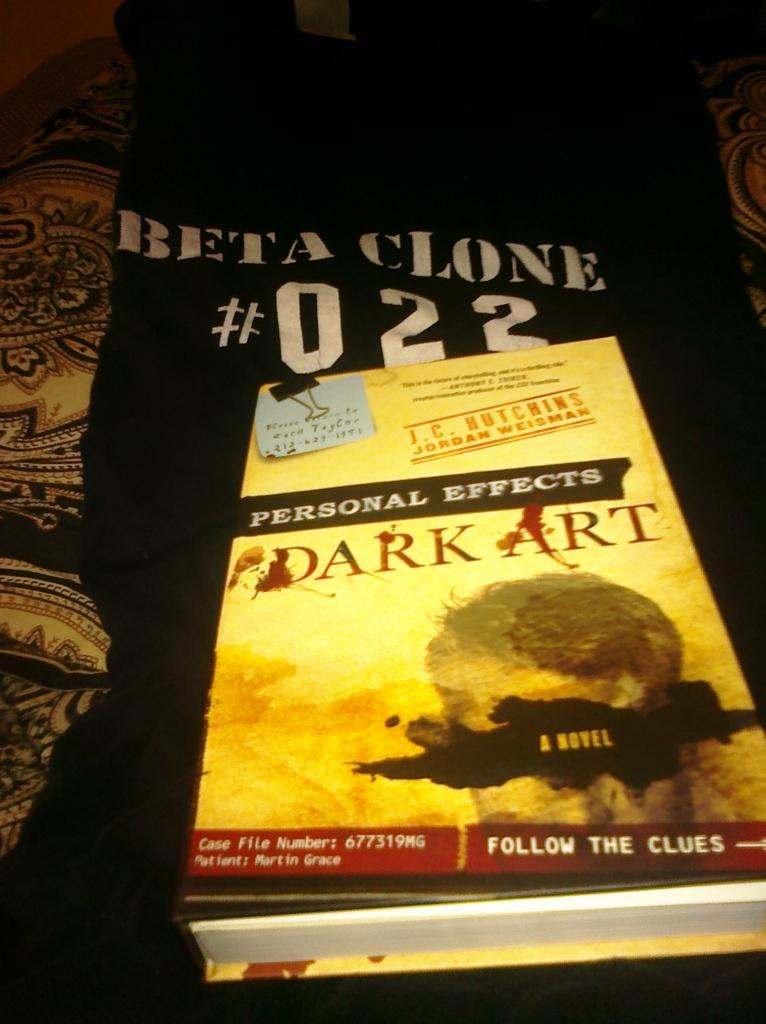<image>
Share a concise interpretation of the image provided. A book titled Dark Art sits on a black shirt. 